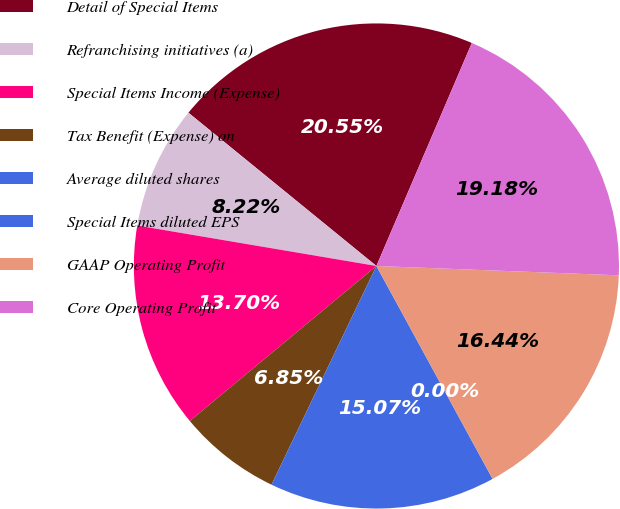<chart> <loc_0><loc_0><loc_500><loc_500><pie_chart><fcel>Detail of Special Items<fcel>Refranchising initiatives (a)<fcel>Special Items Income (Expense)<fcel>Tax Benefit (Expense) on<fcel>Average diluted shares<fcel>Special Items diluted EPS<fcel>GAAP Operating Profit<fcel>Core Operating Profit<nl><fcel>20.55%<fcel>8.22%<fcel>13.7%<fcel>6.85%<fcel>15.07%<fcel>0.0%<fcel>16.44%<fcel>19.18%<nl></chart> 